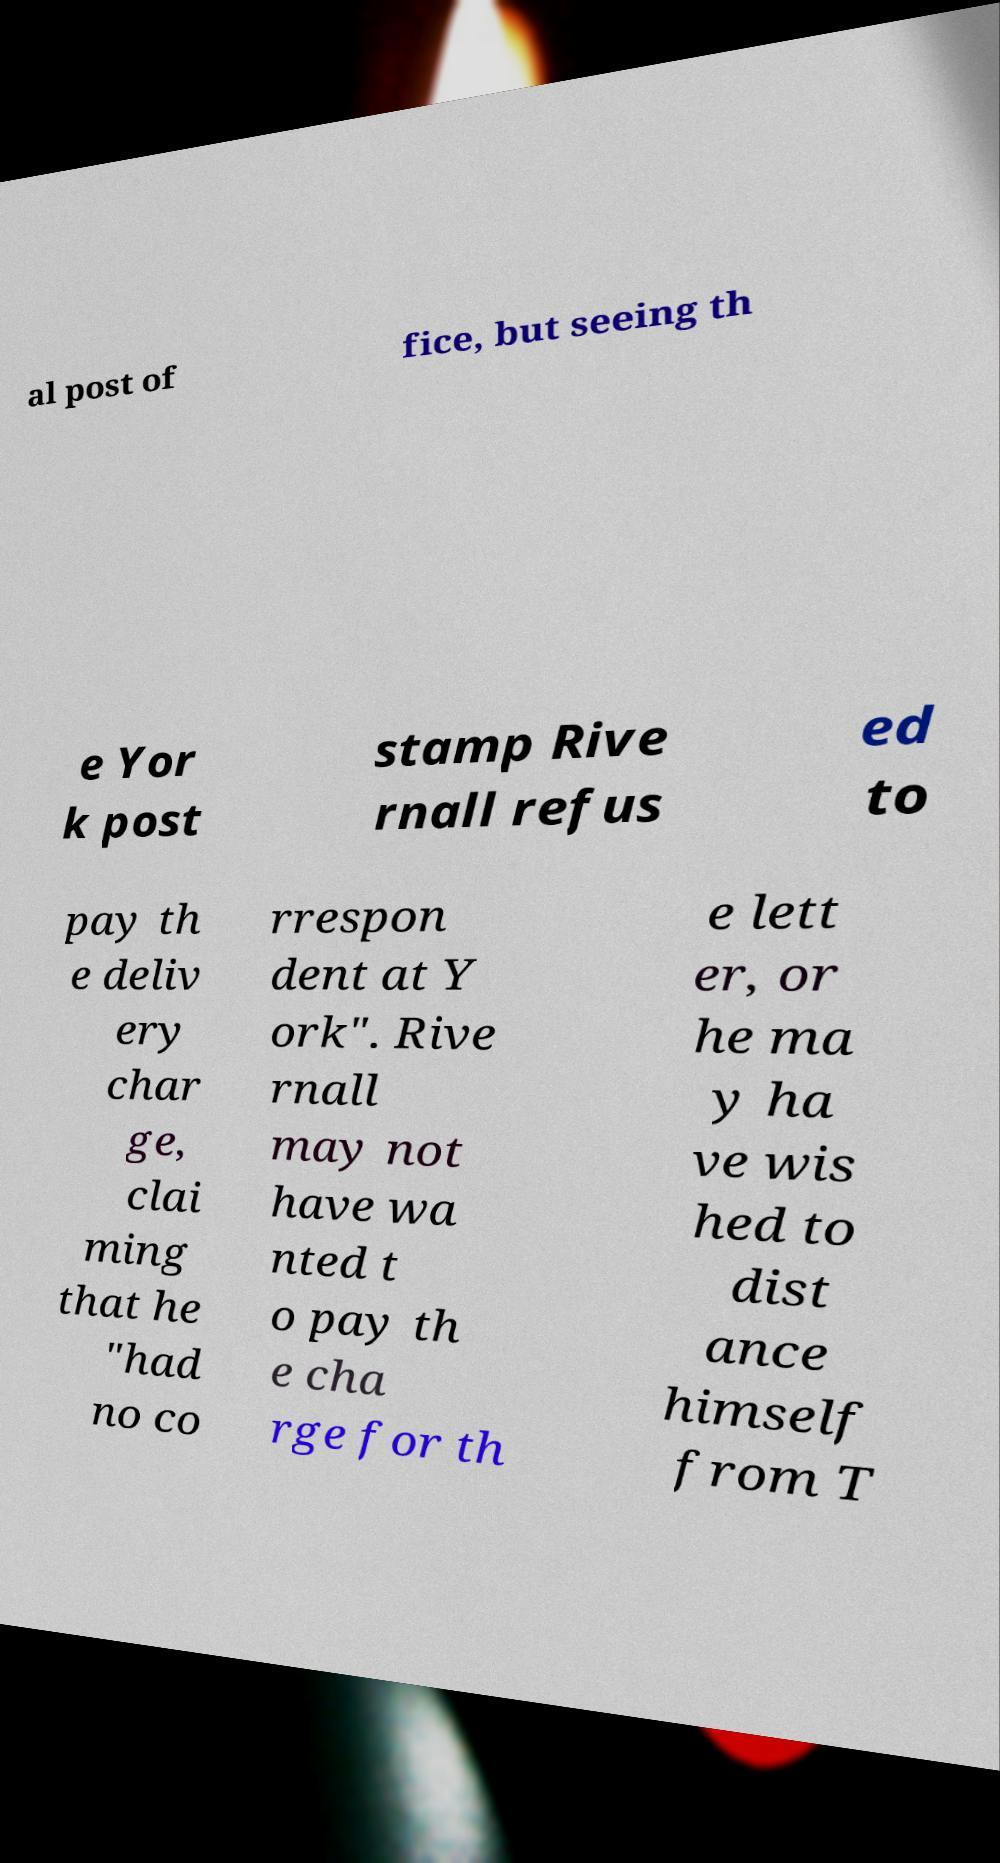Please read and relay the text visible in this image. What does it say? al post of fice, but seeing th e Yor k post stamp Rive rnall refus ed to pay th e deliv ery char ge, clai ming that he "had no co rrespon dent at Y ork". Rive rnall may not have wa nted t o pay th e cha rge for th e lett er, or he ma y ha ve wis hed to dist ance himself from T 